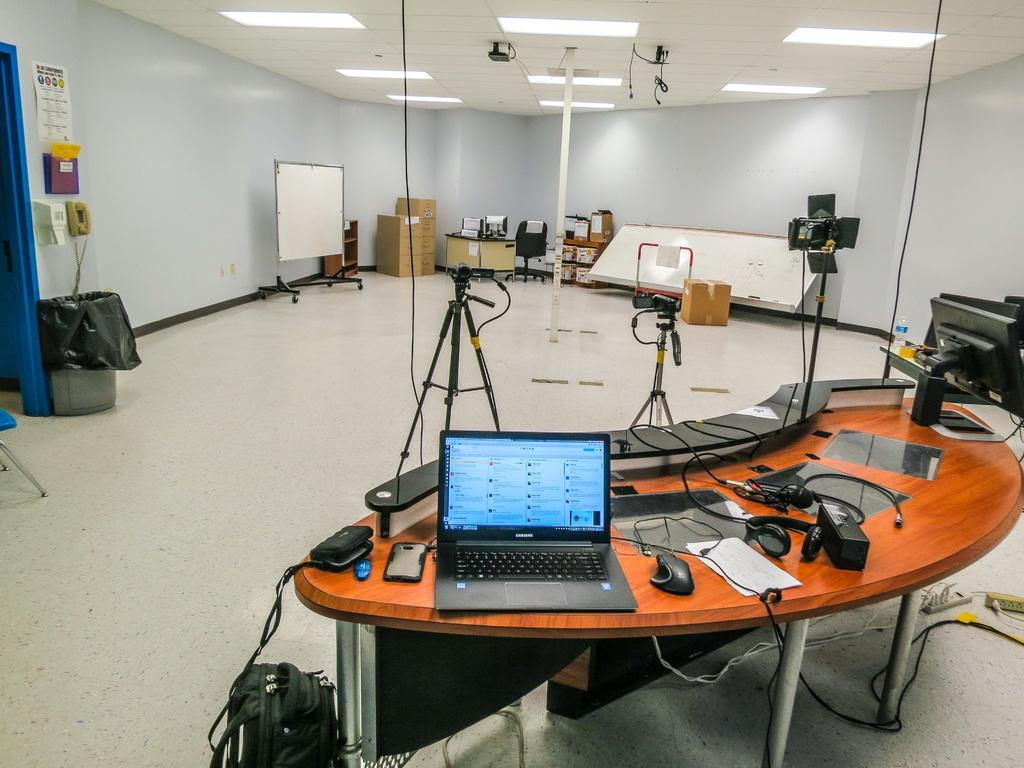What is: What electronic device is on the table in the image? There is a laptop on the table in the image. What else can be seen on the table besides the laptop? There is a cable and a phone on the table, as well as an unspecified object. What is the background of the image? There is a wall in the image. Are there any friends visible in the image? There is no indication of friends in the image; it only shows a laptop, cable, phone, unspecified object, and a wall. What type of furniture is present in the image? There is no furniture visible in the image; it only shows a table with various objects on it and a wall in the background. 